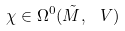<formula> <loc_0><loc_0><loc_500><loc_500>\chi \in \Omega ^ { 0 } ( \tilde { M } , \ V )</formula> 